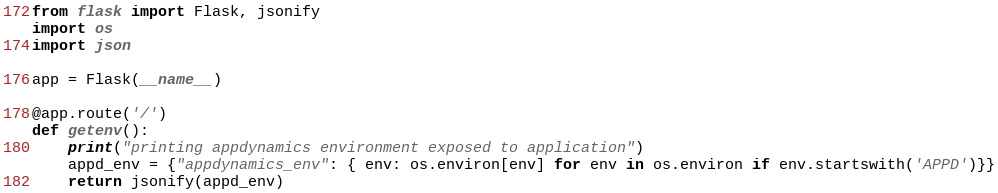Convert code to text. <code><loc_0><loc_0><loc_500><loc_500><_Python_>from flask import Flask, jsonify
import os
import json

app = Flask(__name__)

@app.route('/')
def getenv():
    print("printing appdynamics environment exposed to application")
    appd_env = {"appdynamics_env": { env: os.environ[env] for env in os.environ if env.startswith('APPD')}}
    return jsonify(appd_env)
</code> 